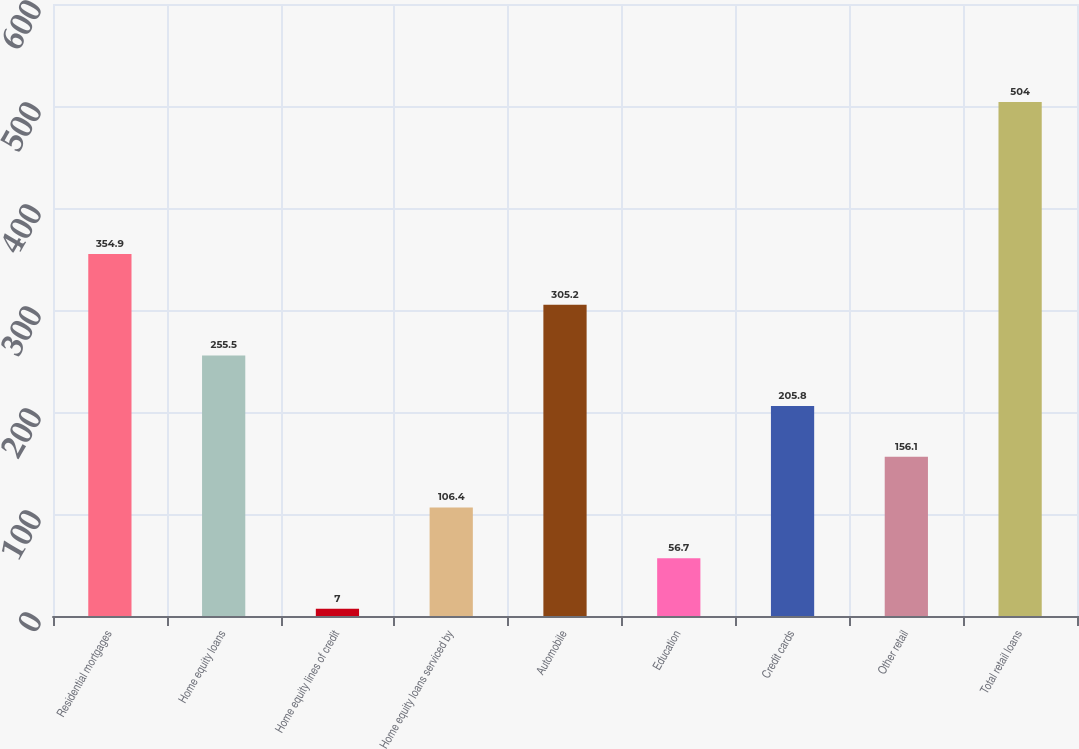<chart> <loc_0><loc_0><loc_500><loc_500><bar_chart><fcel>Residential mortgages<fcel>Home equity loans<fcel>Home equity lines of credit<fcel>Home equity loans serviced by<fcel>Automobile<fcel>Education<fcel>Credit cards<fcel>Other retail<fcel>Total retail loans<nl><fcel>354.9<fcel>255.5<fcel>7<fcel>106.4<fcel>305.2<fcel>56.7<fcel>205.8<fcel>156.1<fcel>504<nl></chart> 